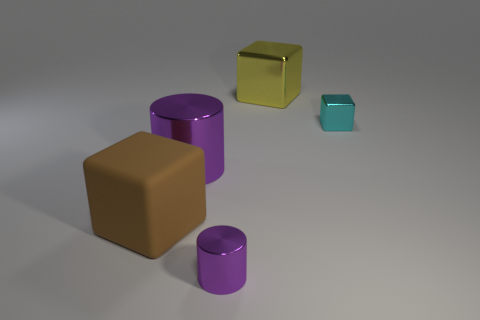Add 1 yellow metallic objects. How many objects exist? 6 Subtract all cylinders. How many objects are left? 3 Add 1 small cyan objects. How many small cyan objects are left? 2 Add 5 red metal blocks. How many red metal blocks exist? 5 Subtract 0 cyan cylinders. How many objects are left? 5 Subtract all small blue rubber objects. Subtract all brown objects. How many objects are left? 4 